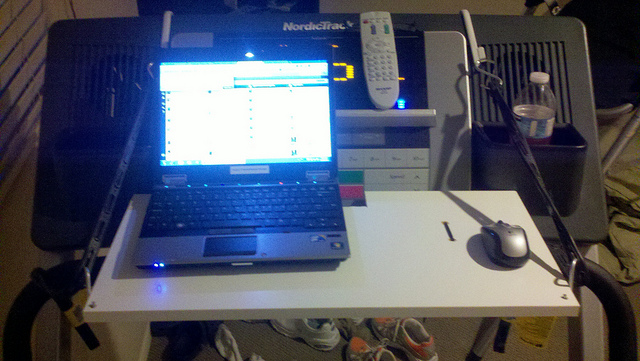Identify the text displayed in this image. NordicTrac 